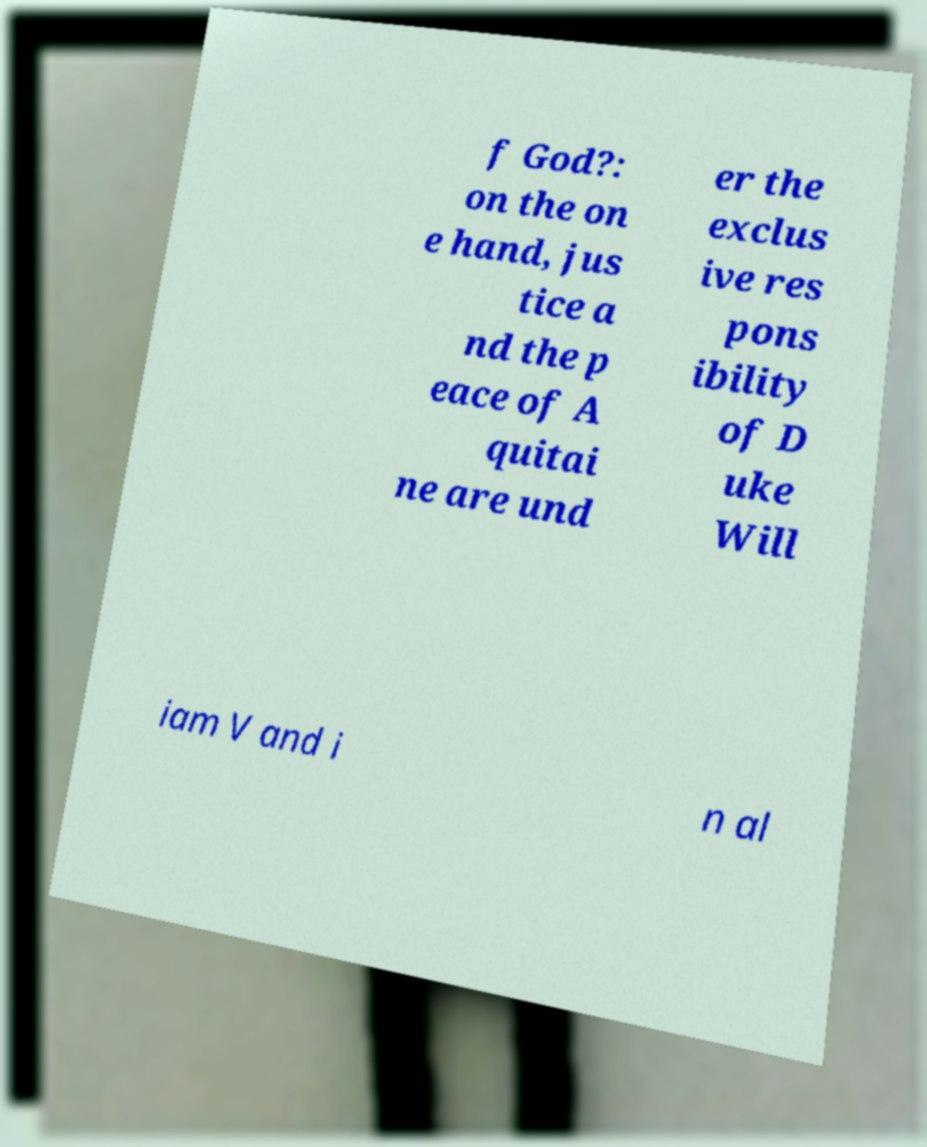Could you extract and type out the text from this image? f God?: on the on e hand, jus tice a nd the p eace of A quitai ne are und er the exclus ive res pons ibility of D uke Will iam V and i n al 